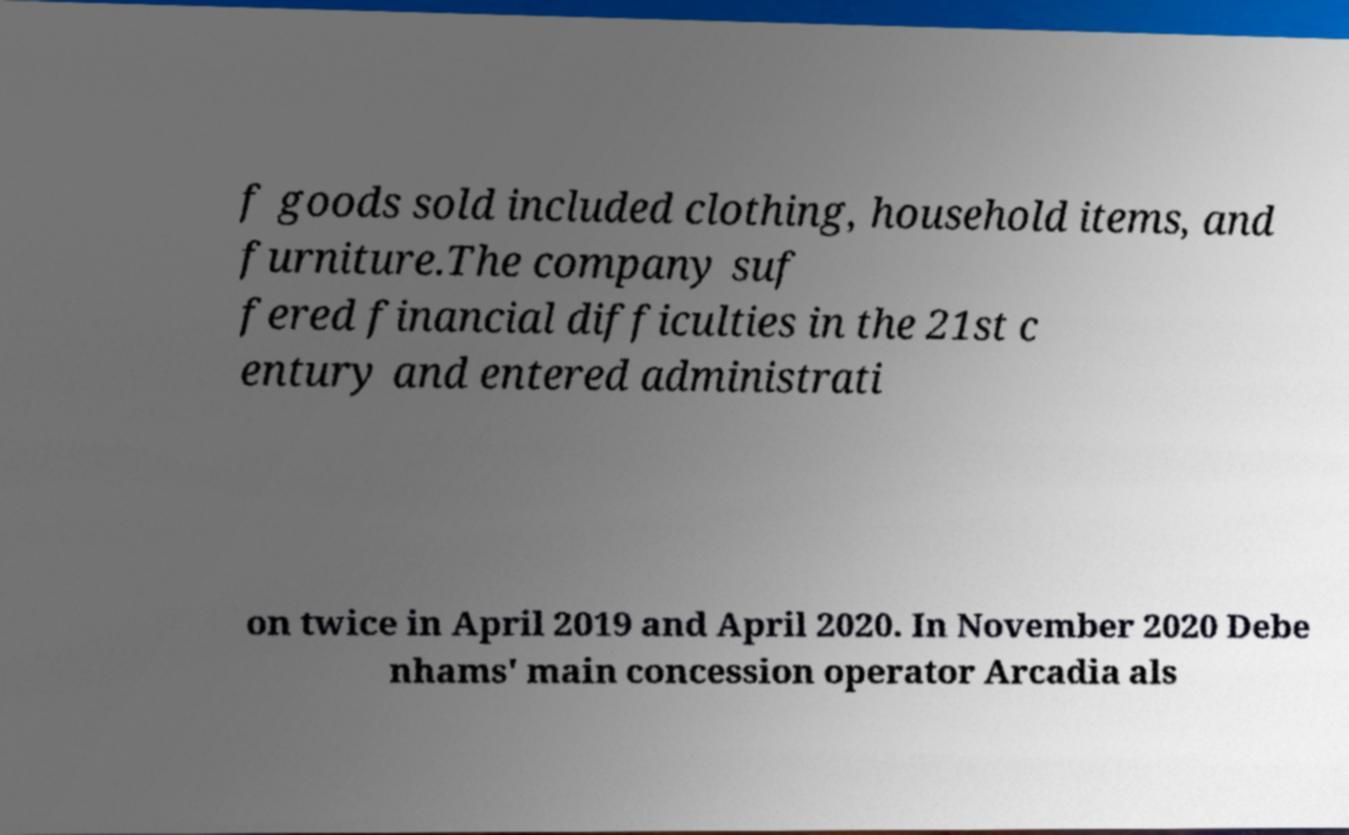Can you read and provide the text displayed in the image?This photo seems to have some interesting text. Can you extract and type it out for me? f goods sold included clothing, household items, and furniture.The company suf fered financial difficulties in the 21st c entury and entered administrati on twice in April 2019 and April 2020. In November 2020 Debe nhams' main concession operator Arcadia als 